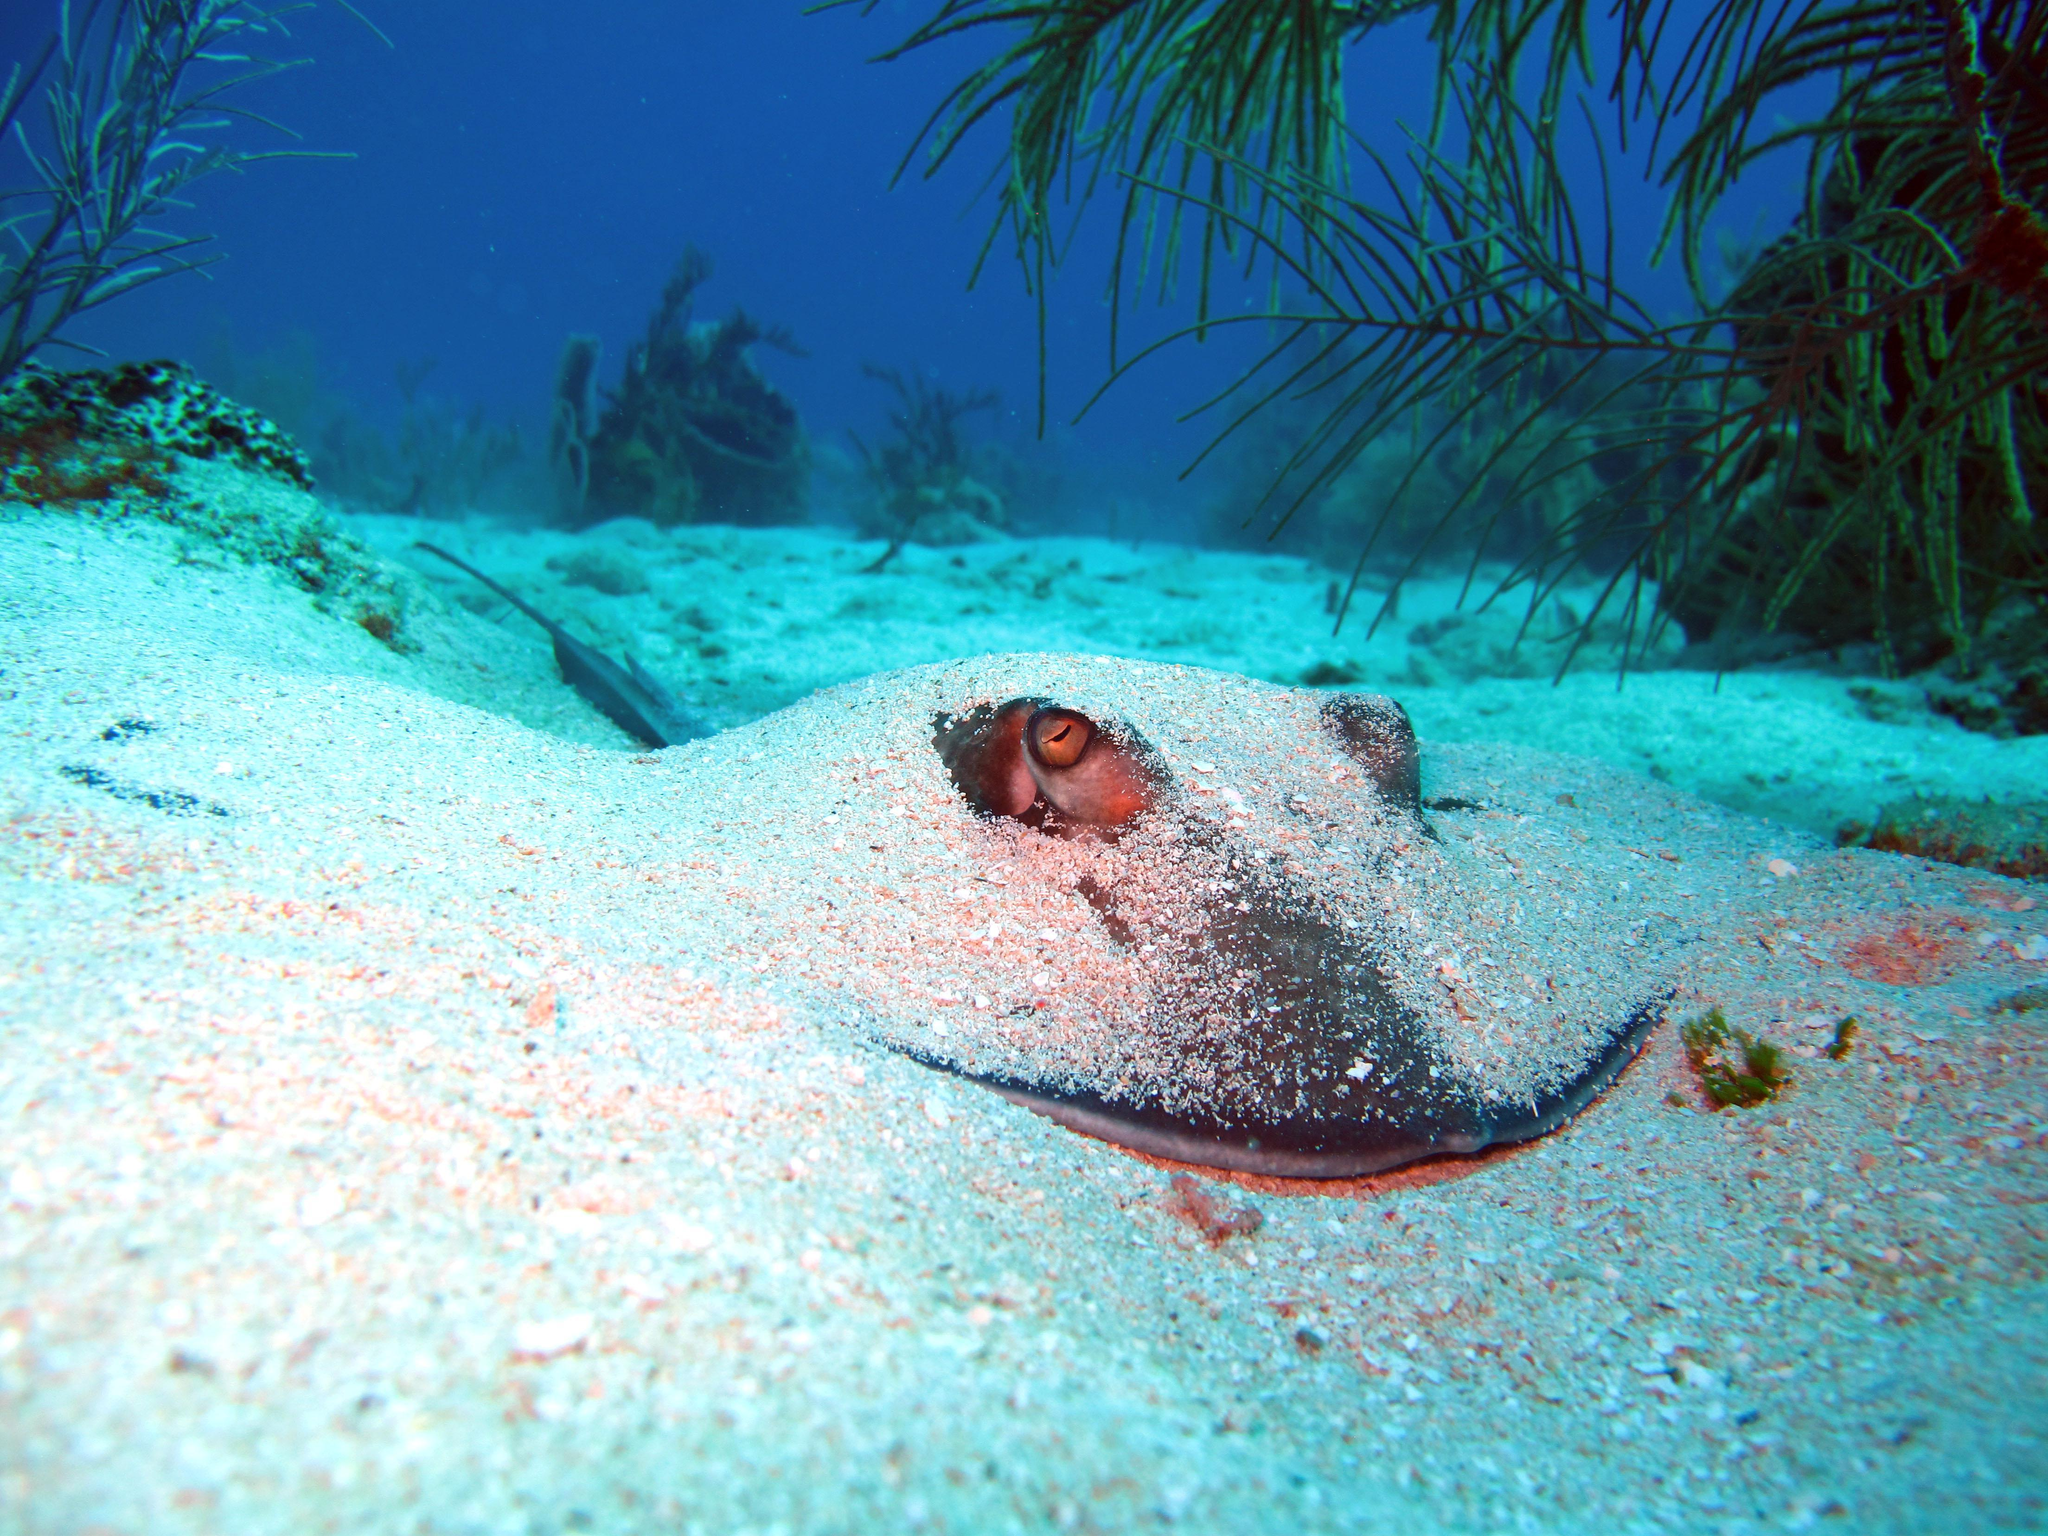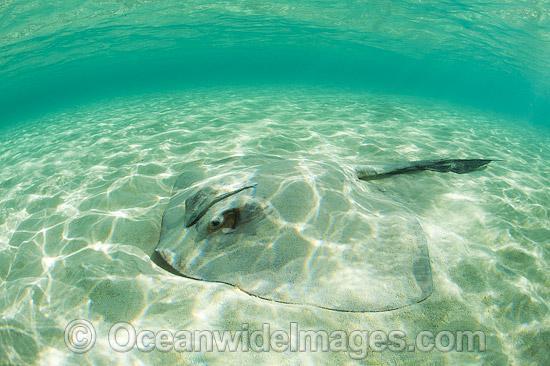The first image is the image on the left, the second image is the image on the right. Evaluate the accuracy of this statement regarding the images: "The stingray in the left image is nearly covered in sand.". Is it true? Answer yes or no. Yes. 